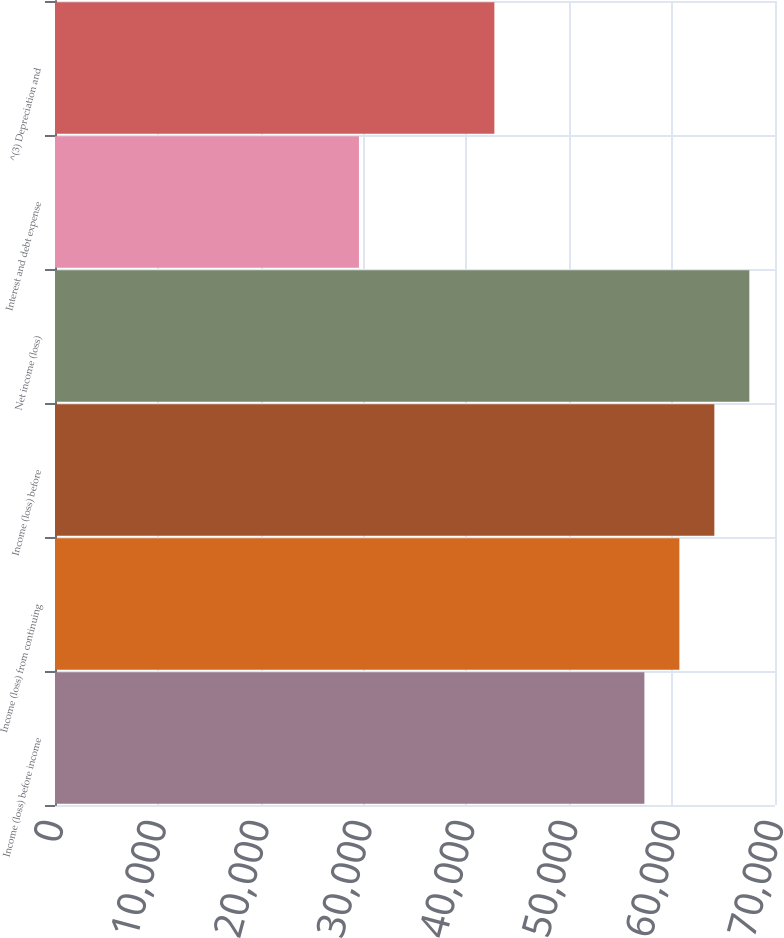Convert chart. <chart><loc_0><loc_0><loc_500><loc_500><bar_chart><fcel>Income (loss) before income<fcel>Income (loss) from continuing<fcel>Income (loss) before<fcel>Net income (loss)<fcel>Interest and debt expense<fcel>^(3) Depreciation and<nl><fcel>57302<fcel>60702.8<fcel>64103.6<fcel>67504.4<fcel>29551<fcel>42717<nl></chart> 